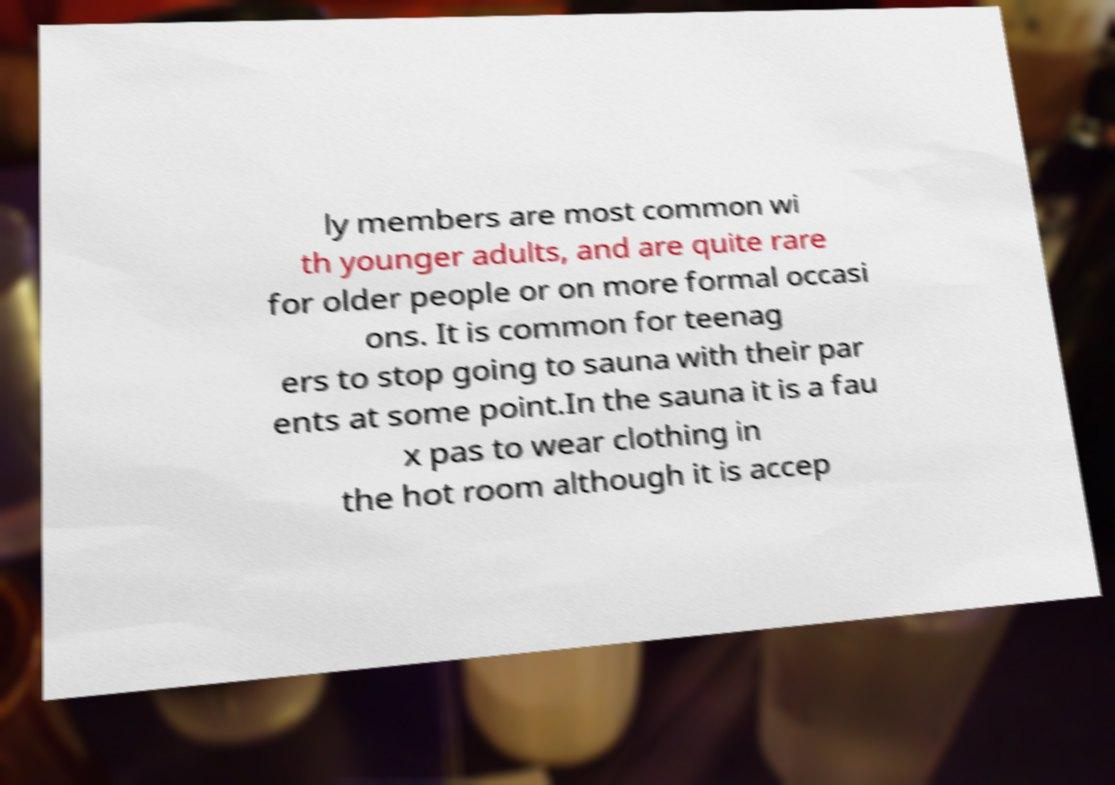Could you assist in decoding the text presented in this image and type it out clearly? ly members are most common wi th younger adults, and are quite rare for older people or on more formal occasi ons. It is common for teenag ers to stop going to sauna with their par ents at some point.In the sauna it is a fau x pas to wear clothing in the hot room although it is accep 